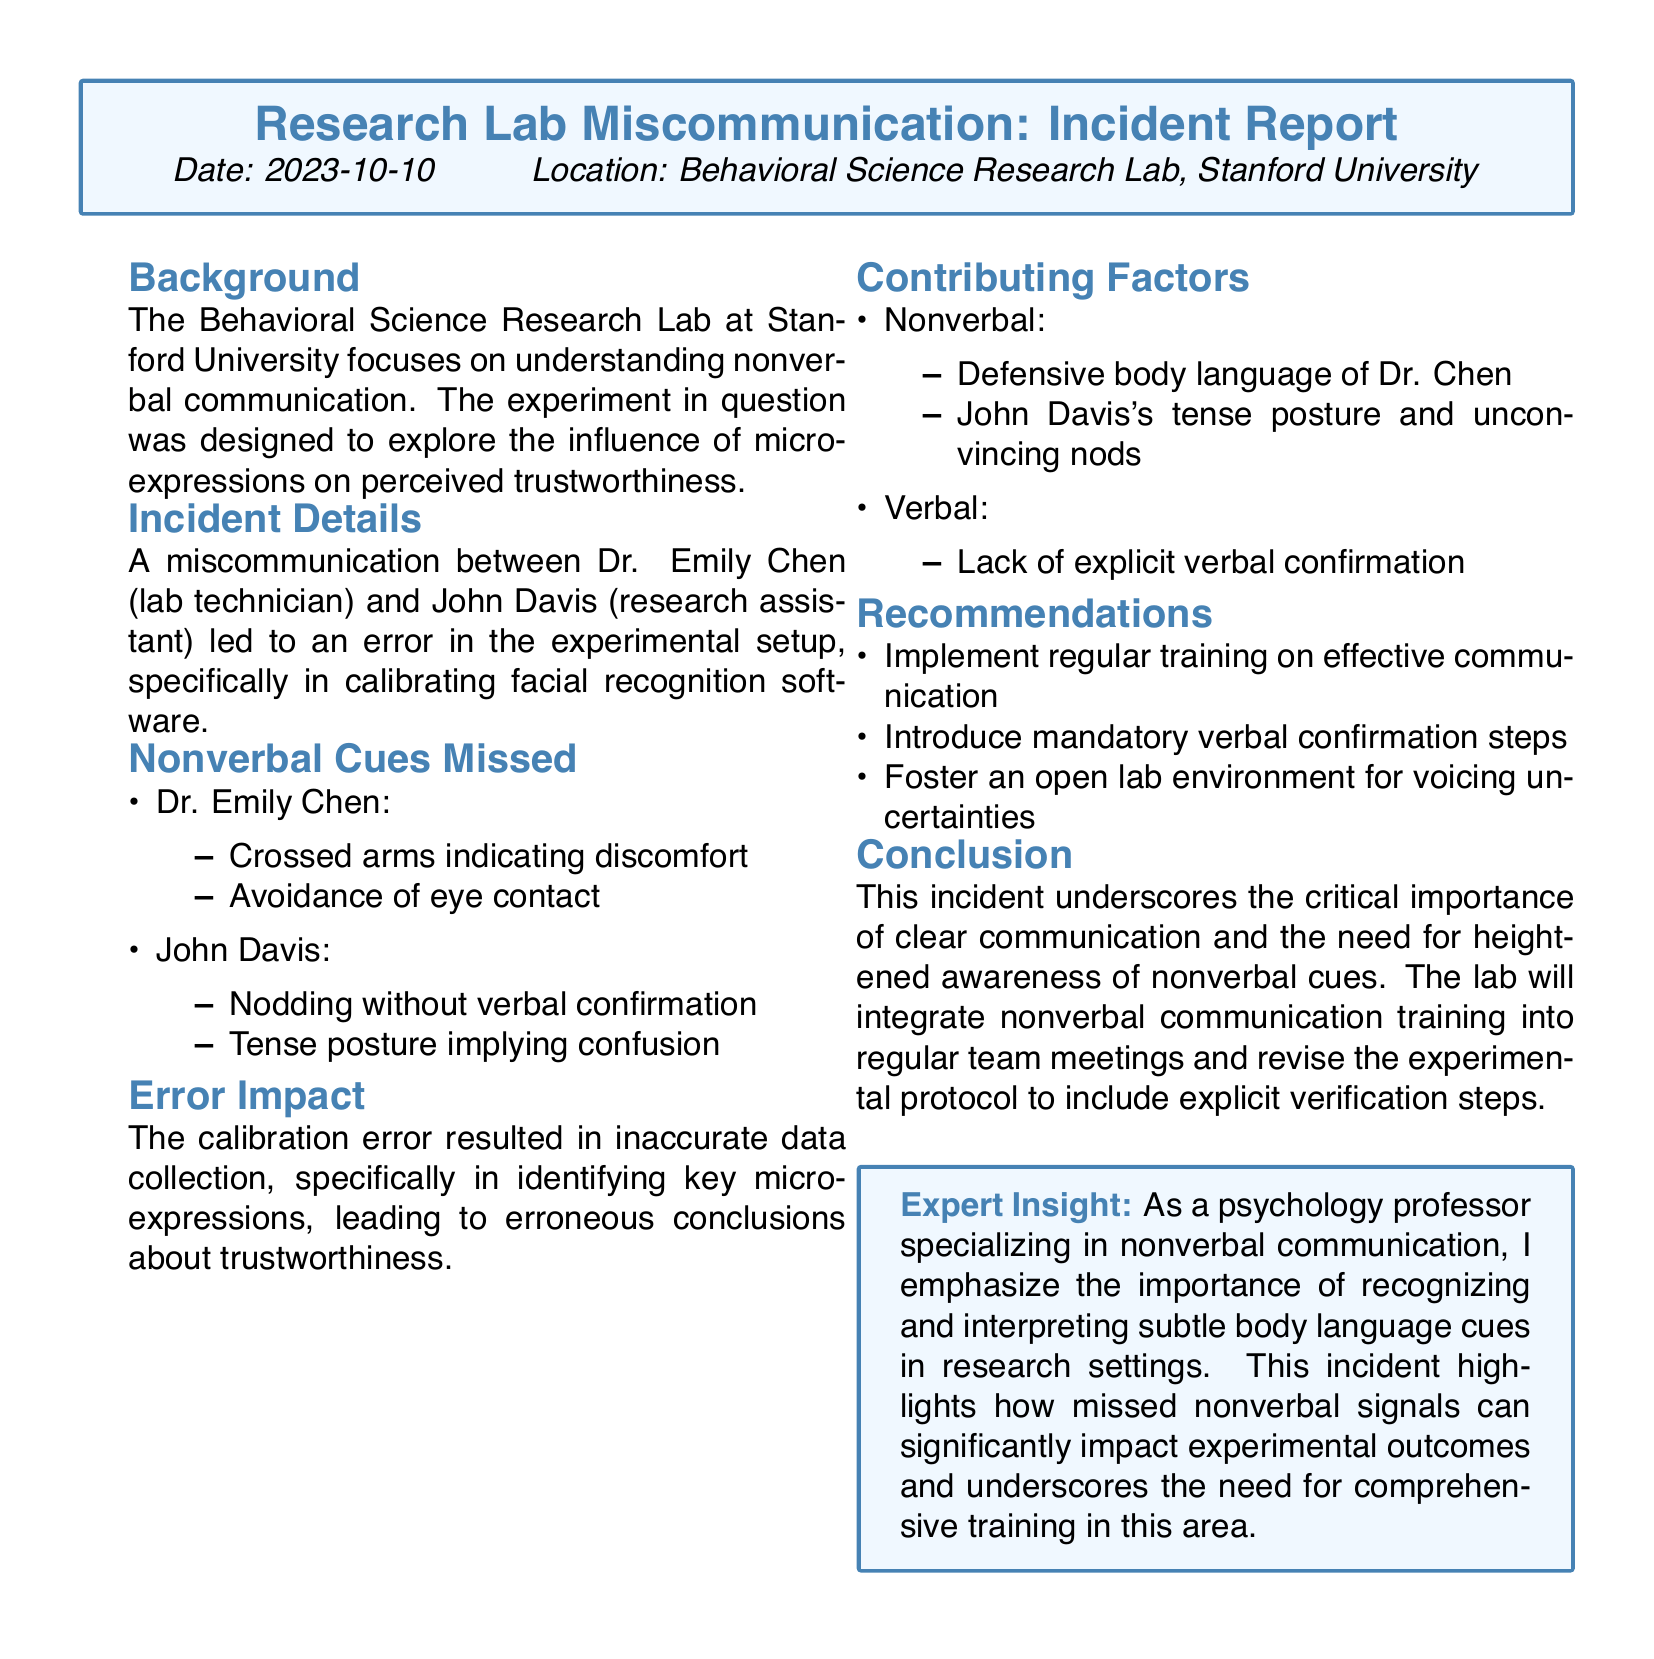what is the date of the incident? The date of the incident is mentioned in the report as 2023-10-10.
Answer: 2023-10-10 who are the two individuals involved in the miscommunication? The individuals involved are Dr. Emily Chen and John Davis, as stated in the incident details.
Answer: Dr. Emily Chen and John Davis what specific error occurred in the experimental setup? The specific error was in calibrating facial recognition software, as noted in the incident details.
Answer: calibrating facial recognition software what nonverbal cue did Dr. Chen exhibit? Dr. Chen exhibited crossed arms indicating discomfort, according to the nonverbal cues section.
Answer: crossed arms what was one of the recommendations provided in the report? One recommendation is to implement regular training on effective communication, as highlighted in the recommendations section.
Answer: implement regular training on effective communication what impact did the calibration error have on the experiment? The calibration error led to inaccurate data collection regarding key micro-expressions, as described in the error impact section.
Answer: inaccurate data collection how did John Davis's body language contribute to the miscommunication? John Davis's tense posture implied confusion, which is mentioned in the contributing factors section.
Answer: tense posture what is the main focus of the Behavioral Science Research Lab? The lab focuses on understanding nonverbal communication, as indicated in the background section.
Answer: understanding nonverbal communication what type of communication training is suggested for the lab team? The report suggests nonverbal communication training should be integrated into regular team meetings.
Answer: nonverbal communication training 